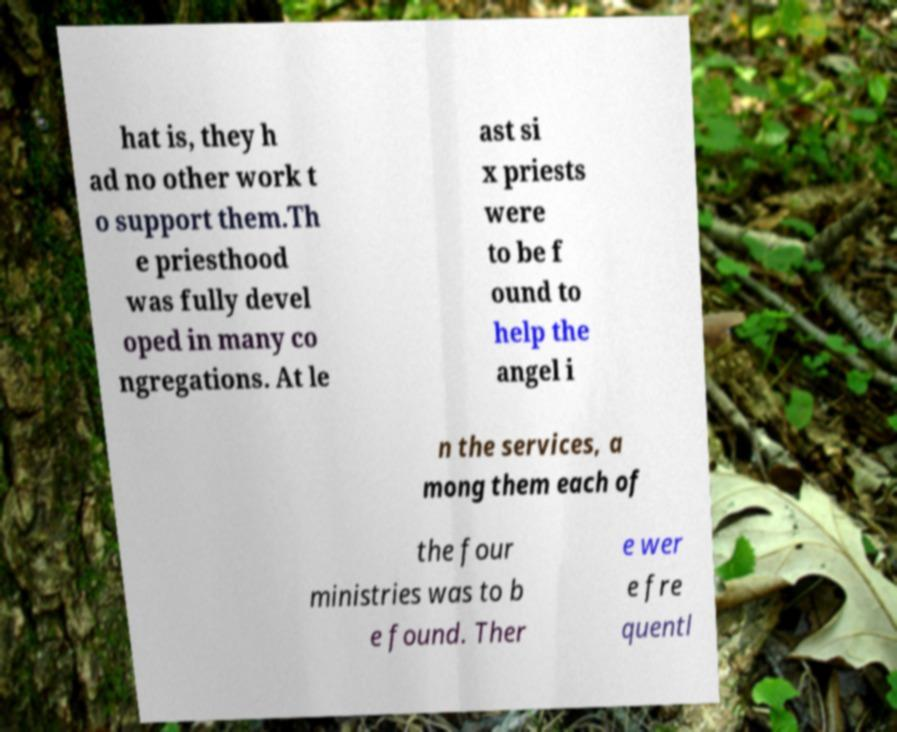There's text embedded in this image that I need extracted. Can you transcribe it verbatim? hat is, they h ad no other work t o support them.Th e priesthood was fully devel oped in many co ngregations. At le ast si x priests were to be f ound to help the angel i n the services, a mong them each of the four ministries was to b e found. Ther e wer e fre quentl 